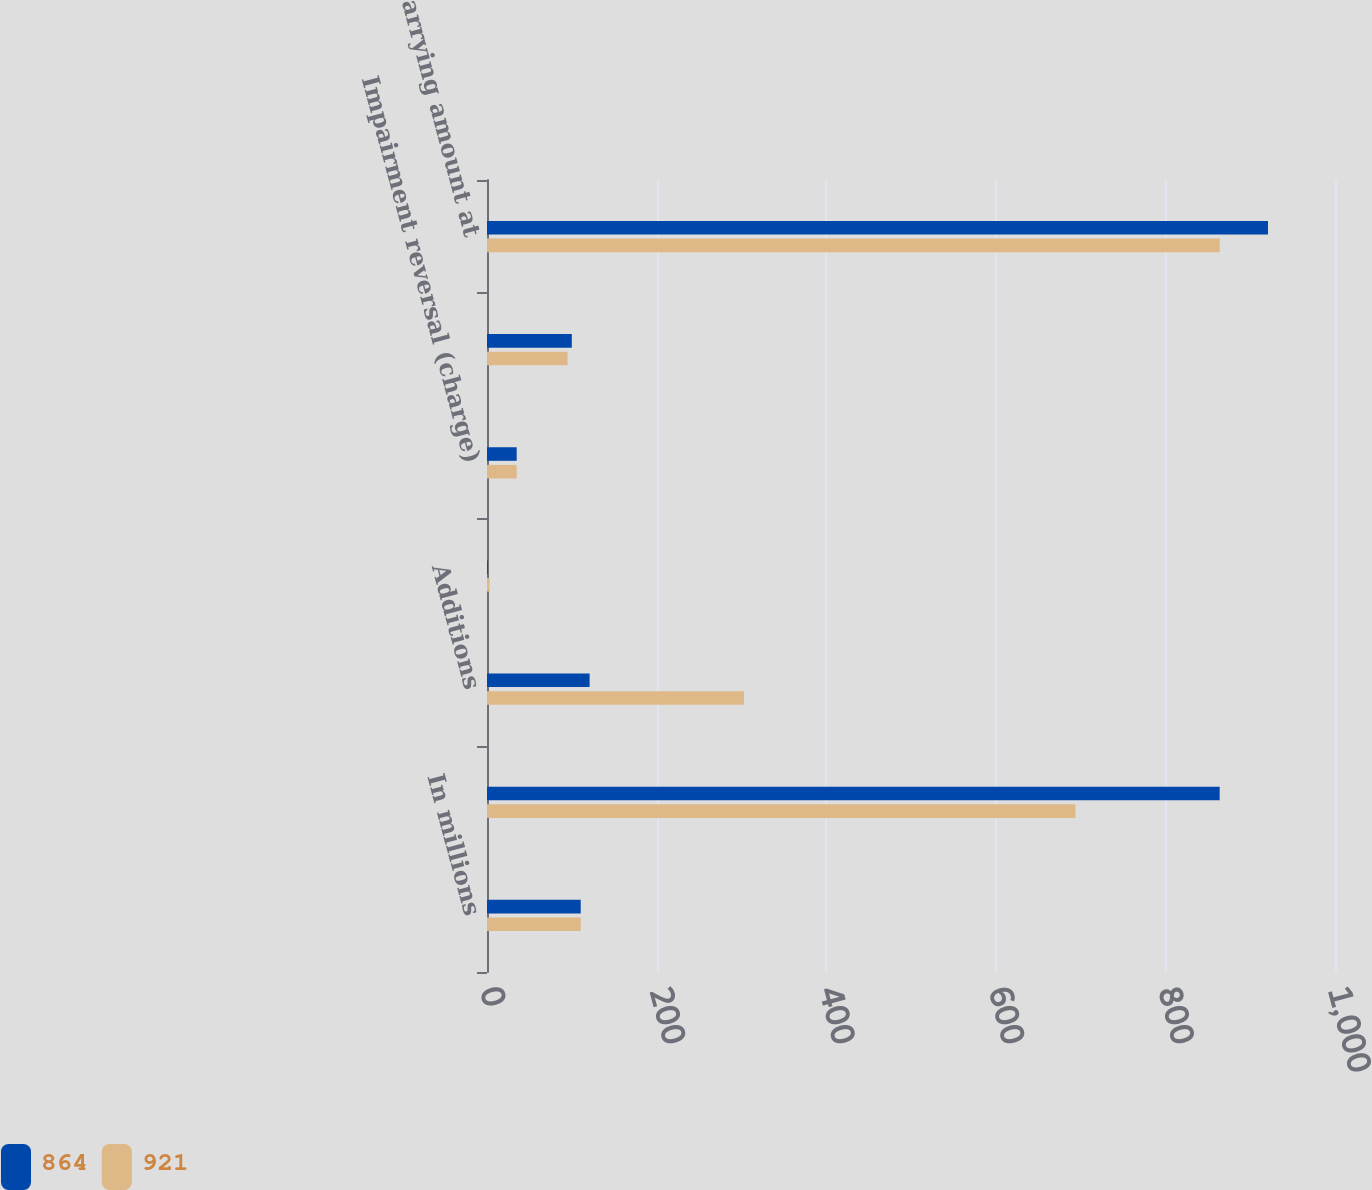Convert chart to OTSL. <chart><loc_0><loc_0><loc_500><loc_500><stacked_bar_chart><ecel><fcel>In millions<fcel>January 1<fcel>Additions<fcel>Acquisition adjustment<fcel>Impairment reversal (charge)<fcel>Amortization expense<fcel>Net carrying amount at<nl><fcel>864<fcel>110.5<fcel>864<fcel>121<fcel>1<fcel>35<fcel>100<fcel>921<nl><fcel>921<fcel>110.5<fcel>694<fcel>303<fcel>3<fcel>35<fcel>95<fcel>864<nl></chart> 